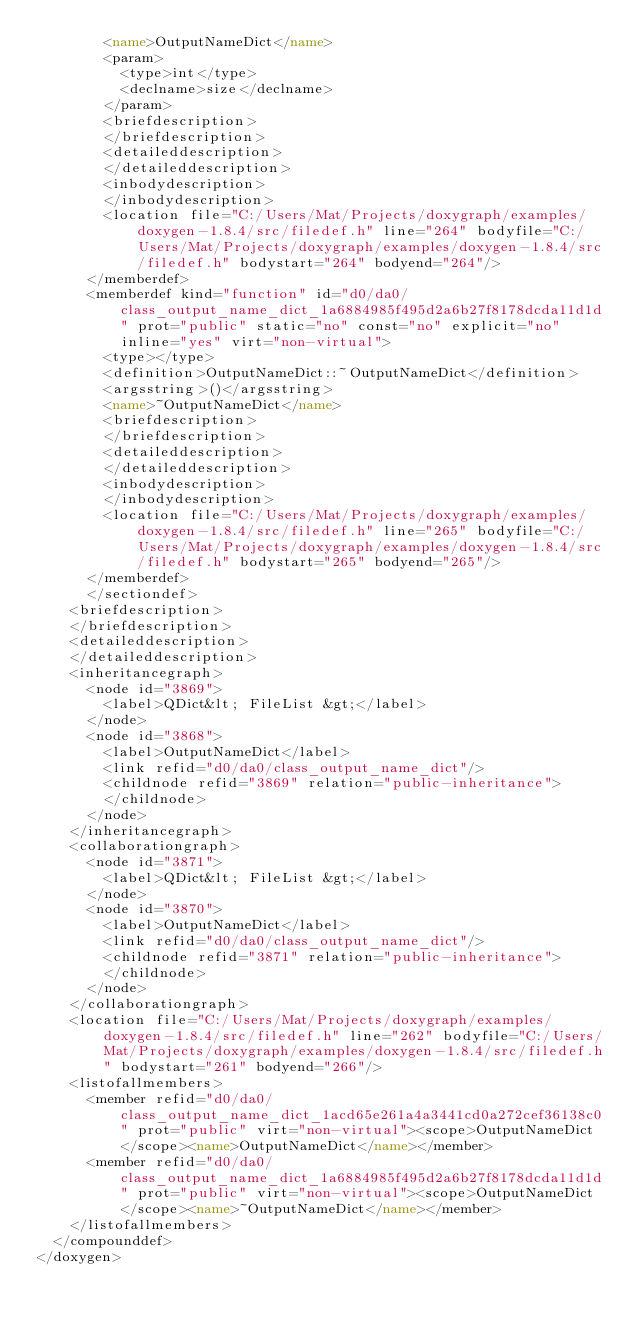Convert code to text. <code><loc_0><loc_0><loc_500><loc_500><_XML_>        <name>OutputNameDict</name>
        <param>
          <type>int</type>
          <declname>size</declname>
        </param>
        <briefdescription>
        </briefdescription>
        <detaileddescription>
        </detaileddescription>
        <inbodydescription>
        </inbodydescription>
        <location file="C:/Users/Mat/Projects/doxygraph/examples/doxygen-1.8.4/src/filedef.h" line="264" bodyfile="C:/Users/Mat/Projects/doxygraph/examples/doxygen-1.8.4/src/filedef.h" bodystart="264" bodyend="264"/>
      </memberdef>
      <memberdef kind="function" id="d0/da0/class_output_name_dict_1a6884985f495d2a6b27f8178dcda11d1d" prot="public" static="no" const="no" explicit="no" inline="yes" virt="non-virtual">
        <type></type>
        <definition>OutputNameDict::~OutputNameDict</definition>
        <argsstring>()</argsstring>
        <name>~OutputNameDict</name>
        <briefdescription>
        </briefdescription>
        <detaileddescription>
        </detaileddescription>
        <inbodydescription>
        </inbodydescription>
        <location file="C:/Users/Mat/Projects/doxygraph/examples/doxygen-1.8.4/src/filedef.h" line="265" bodyfile="C:/Users/Mat/Projects/doxygraph/examples/doxygen-1.8.4/src/filedef.h" bodystart="265" bodyend="265"/>
      </memberdef>
      </sectiondef>
    <briefdescription>
    </briefdescription>
    <detaileddescription>
    </detaileddescription>
    <inheritancegraph>
      <node id="3869">
        <label>QDict&lt; FileList &gt;</label>
      </node>
      <node id="3868">
        <label>OutputNameDict</label>
        <link refid="d0/da0/class_output_name_dict"/>
        <childnode refid="3869" relation="public-inheritance">
        </childnode>
      </node>
    </inheritancegraph>
    <collaborationgraph>
      <node id="3871">
        <label>QDict&lt; FileList &gt;</label>
      </node>
      <node id="3870">
        <label>OutputNameDict</label>
        <link refid="d0/da0/class_output_name_dict"/>
        <childnode refid="3871" relation="public-inheritance">
        </childnode>
      </node>
    </collaborationgraph>
    <location file="C:/Users/Mat/Projects/doxygraph/examples/doxygen-1.8.4/src/filedef.h" line="262" bodyfile="C:/Users/Mat/Projects/doxygraph/examples/doxygen-1.8.4/src/filedef.h" bodystart="261" bodyend="266"/>
    <listofallmembers>
      <member refid="d0/da0/class_output_name_dict_1acd65e261a4a3441cd0a272cef36138c0" prot="public" virt="non-virtual"><scope>OutputNameDict</scope><name>OutputNameDict</name></member>
      <member refid="d0/da0/class_output_name_dict_1a6884985f495d2a6b27f8178dcda11d1d" prot="public" virt="non-virtual"><scope>OutputNameDict</scope><name>~OutputNameDict</name></member>
    </listofallmembers>
  </compounddef>
</doxygen>
</code> 